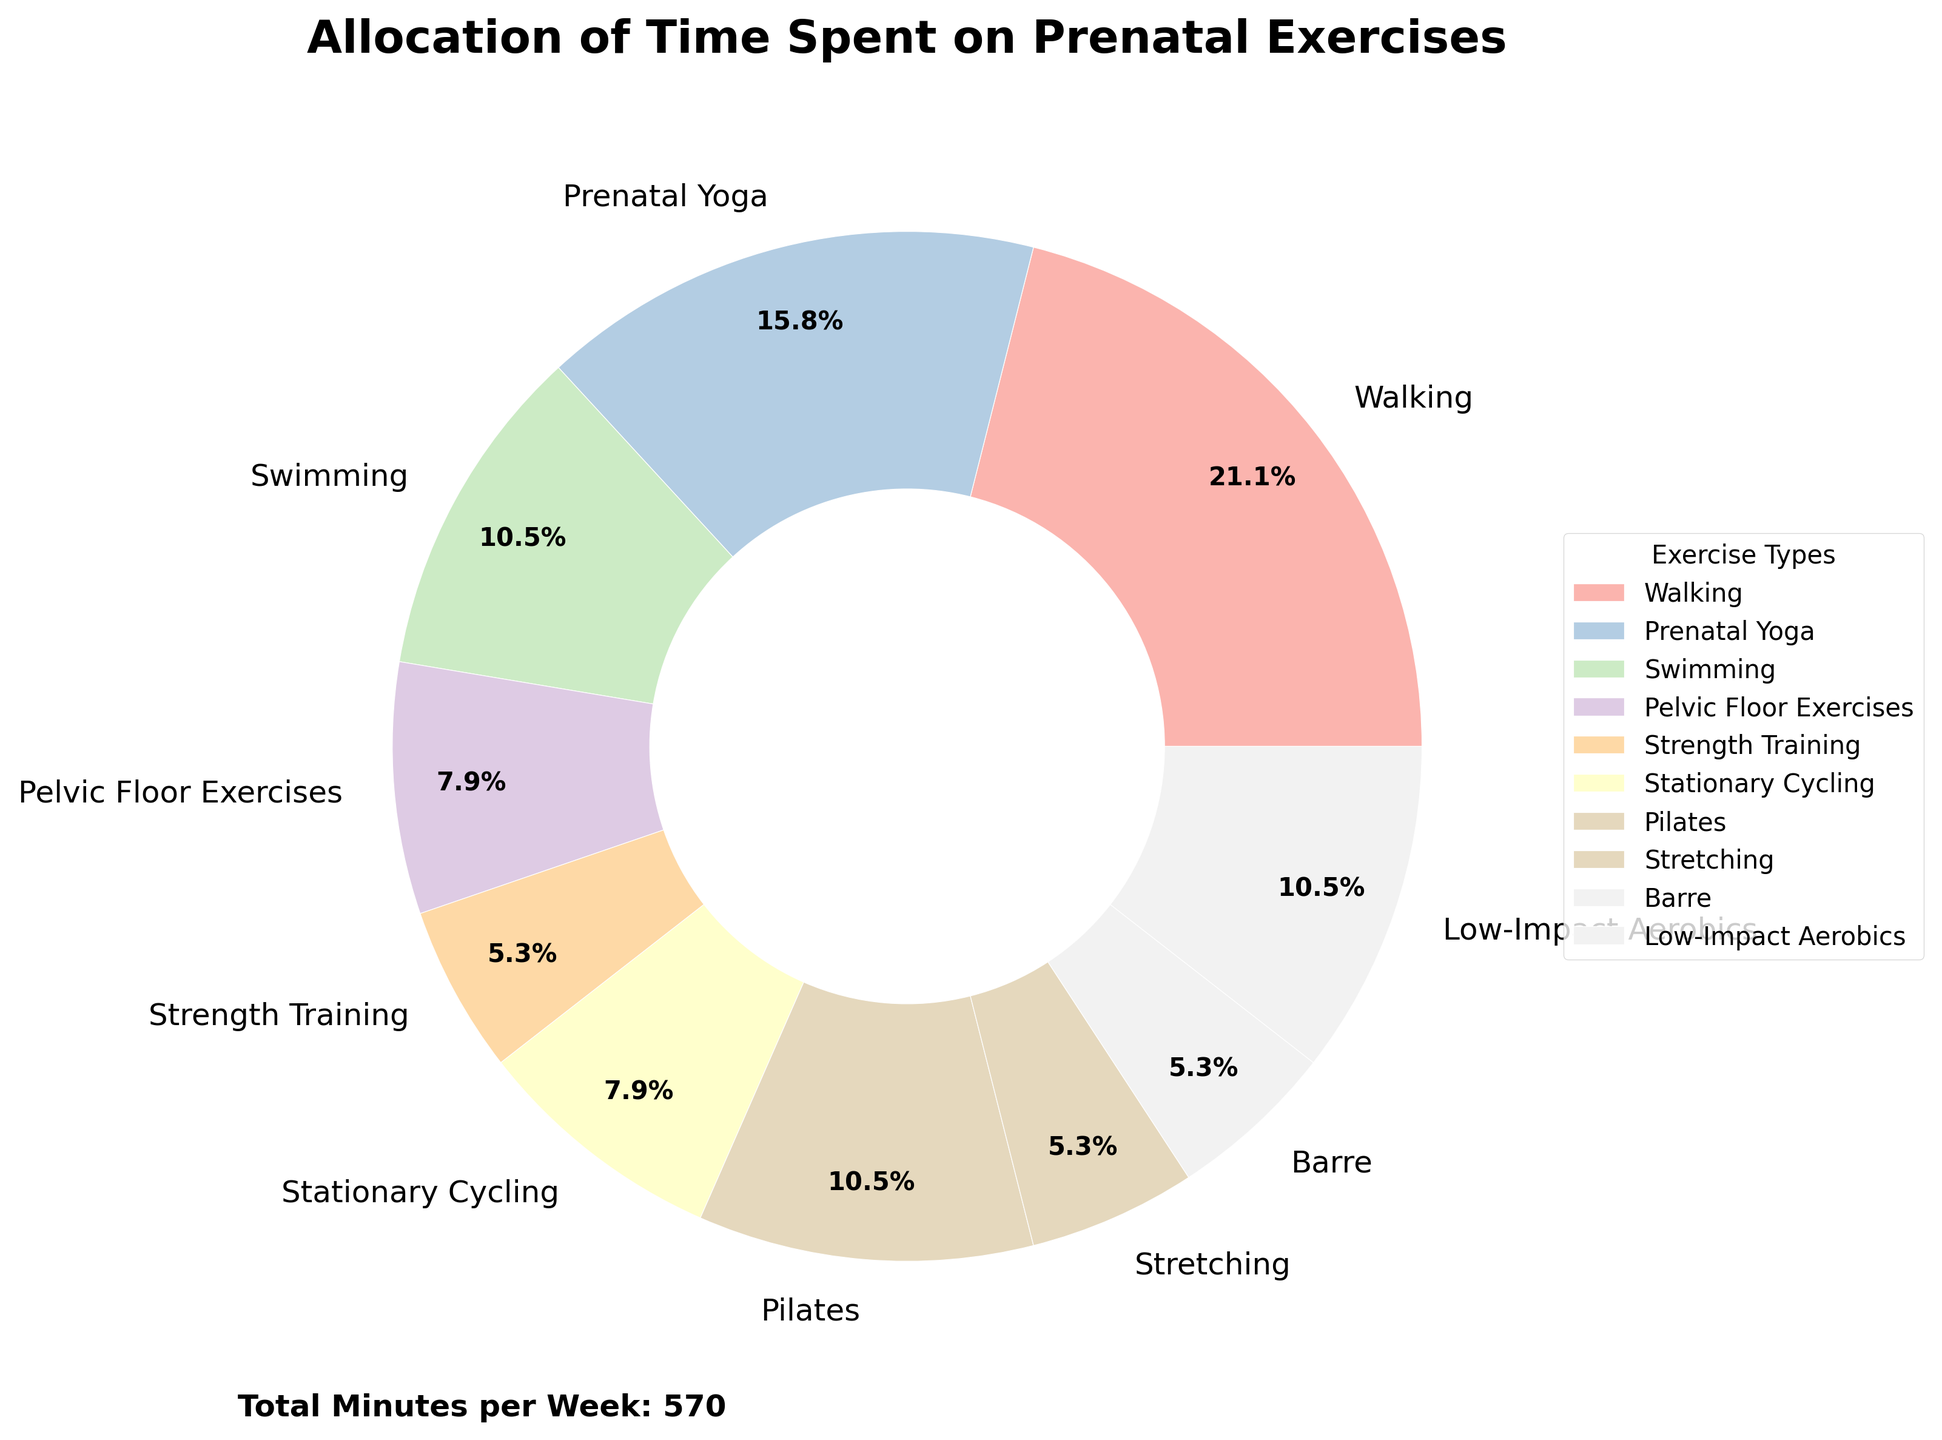What type of exercise takes up the most minutes per week? The pie chart shows various types of prenatal exercises with their respective percentages. The segment for "Walking" is the largest, indicating it takes the most minutes per week.
Answer: Walking Which exercise types take up an equal amount of time per week? By examining the pie chart segments and their percentages, "Pelvic Floor Exercises" and "Stationary Cycling" both account for 45 minutes per week, and "Strength Training," "Stretching," and "Barre" each account for 30 minutes per week.
Answer: Pelvic Floor Exercises and Stationary Cycling; Strength Training, Stretching, and Barre How many minutes per week are spent on prenatal yoga compared to swimming? Prenatal Yoga takes up 90 minutes per week and Swimming takes up 60 minutes per week. Thus, the difference in time spent is 90 - 60 = 30 minutes.
Answer: 30 minutes more on Prenatal Yoga Is more time spent on low-impact aerobics or Pilates? The pie chart indicates that Low-Impact Aerobics and Pilates each account for 60 minutes per week.
Answer: Equal time What's the total time spent on strength training, stretching, and barre combined? Each of these exercises takes 30 minutes per week. Adding them up: 30 + 30 + 30 = 90 minutes.
Answer: 90 minutes Between walking and prenatal yoga, which one takes a higher percentage of the total exercise time? Walking takes up the largest pie segment, which is 120 minutes per week, whereas Prenatal Yoga is 90 minutes per week. 120 minutes is more than 90 minutes.
Answer: Walking Considering swimming and low-impact aerobics, by how many minutes do these exercises differ per week? Both Swimming and Low-Impact Aerobics each account for 60 minutes per week. Therefore, the difference is 0 minutes.
Answer: 0 minutes What proportion of the total weekly exercise time is spent on strength training? To find this, we must calculate the total minutes per week for all exercises, which sums up to 570 minutes. Strength Training takes up 30 minutes, so the proportion is (30/570)×100≈5.26%.
Answer: Approximately 5.26% How does the time spent on walking and stationary cycling compare? Walking takes 120 minutes per week, and Stationary Cycling takes 45 minutes per week. Subtracting these gives 120 - 45 = 75, so Walking is 75 minutes more.
Answer: 75 minutes more on Walking What's the total time spent on all forms of aerobic exercises including walking, stationary cycling, and low-impact aerobics? Adding the minutes for Walking (120), Stationary Cycling (45), and Low-Impact Aerobics (60) gives 120 + 45 + 60 = 225 minutes.
Answer: 225 minutes 